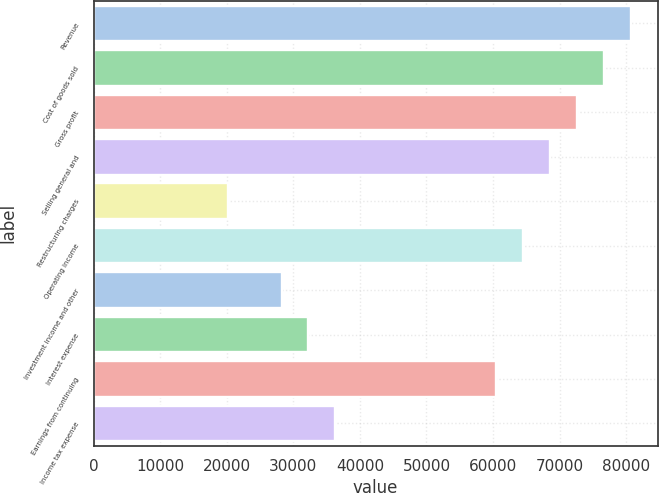<chart> <loc_0><loc_0><loc_500><loc_500><bar_chart><fcel>Revenue<fcel>Cost of goods sold<fcel>Gross profit<fcel>Selling general and<fcel>Restructuring charges<fcel>Operating income<fcel>Investment income and other<fcel>Interest expense<fcel>Earnings from continuing<fcel>Income tax expense<nl><fcel>80678<fcel>76644.1<fcel>72610.2<fcel>68576.3<fcel>20169.5<fcel>64542.4<fcel>28237.3<fcel>32271.2<fcel>60508.5<fcel>36305.1<nl></chart> 